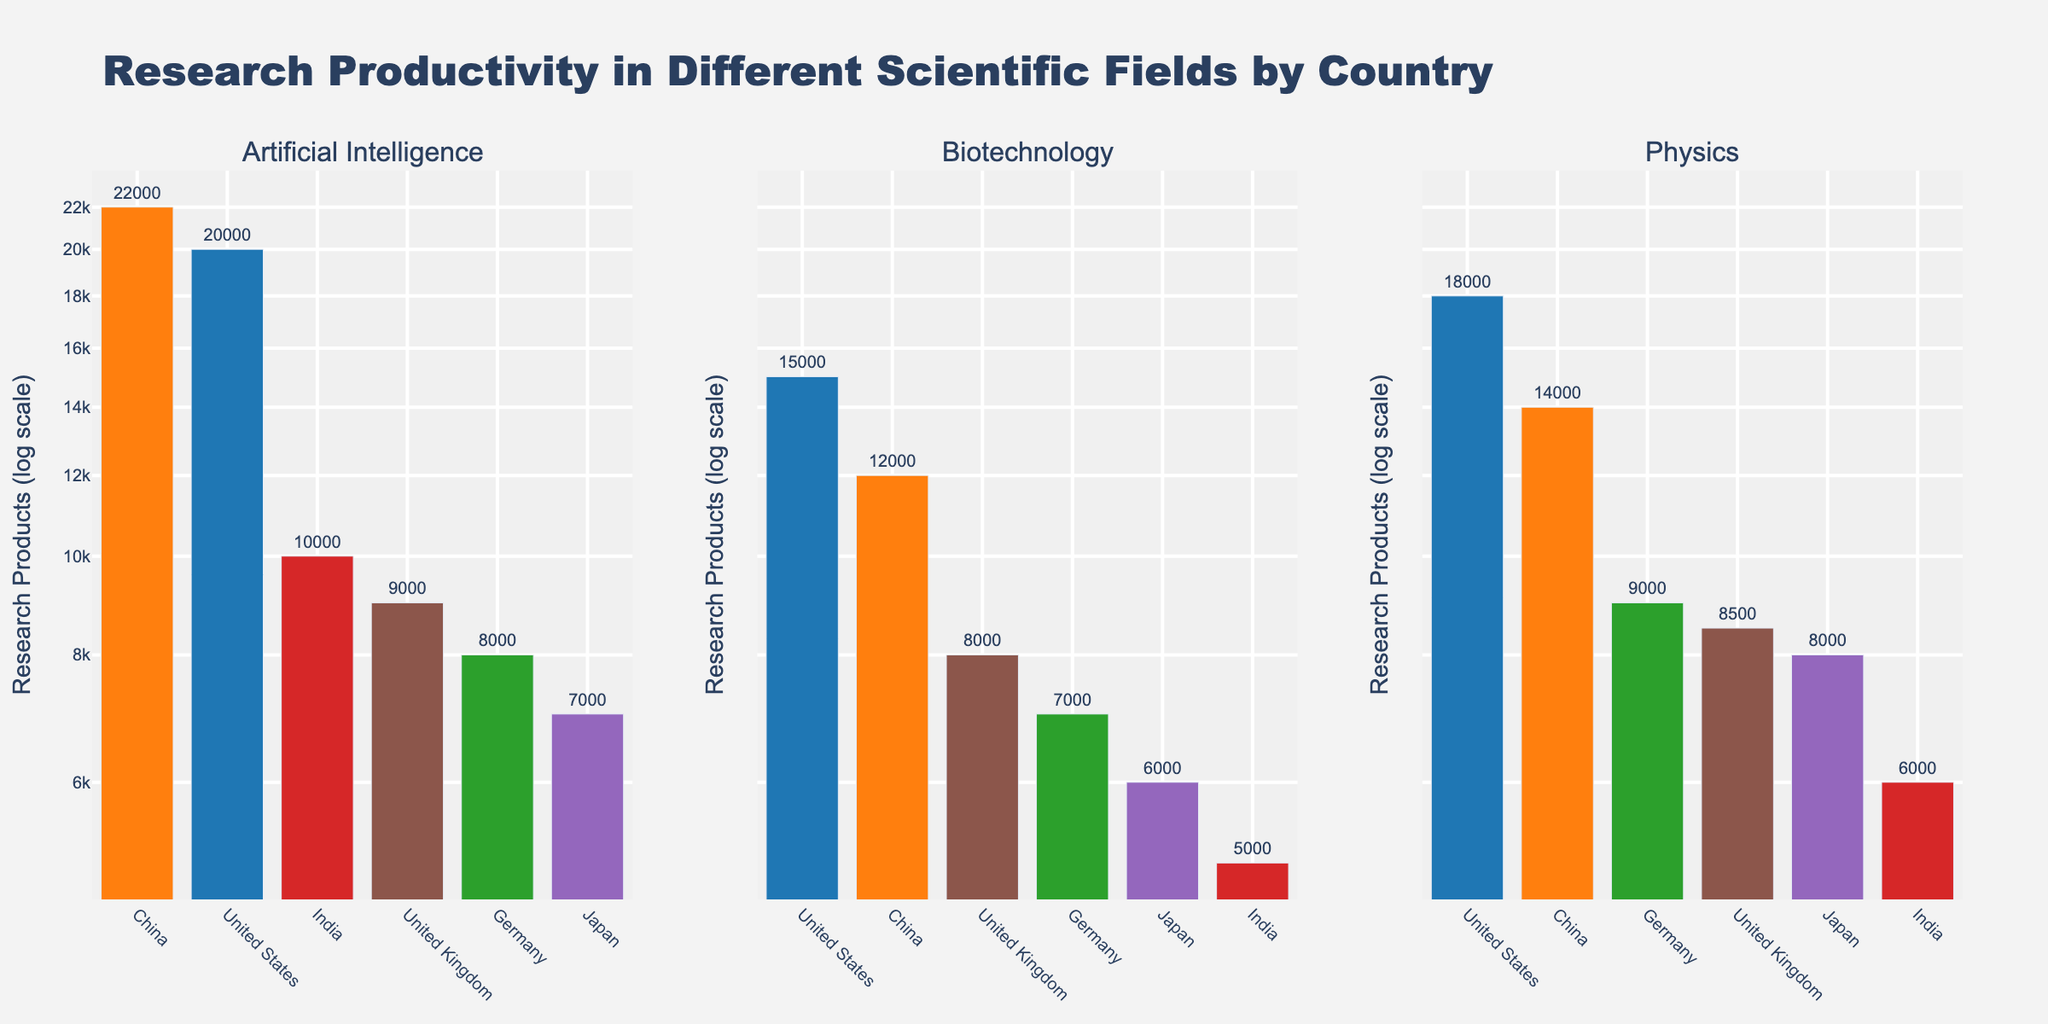Which country has the highest research productivity in Artificial Intelligence? By examining the first subplot titled 'Artificial Intelligence', the bar representing China is the tallest, indicating China has the highest research productivity of 22,000.
Answer: China What is the range of research products in Biotechnology? To find the range, subtract the smallest number of research products from the largest within the Biotechnology subplot. The maximum is 15,000 (United States) and the minimum is 5,000 (India). Therefore, the range is 15,000 - 5,000 = 10,000.
Answer: 10,000 How do India and Japan compare in terms of research productivity in Physics? In the Physics subplot, the bars show that India has 6,000 research products while Japan has 8,000 research products. Comparing these values, Japan has more research productivity.
Answer: Japan has more What is the median value of research productivity for Biotechnology? To find the median, list the research productivity values in ascending order: 5,000 (India), 6,000 (Japan), 7,000 (Germany), 8,000 (United Kingdom), 12,000 (China), and 15,000 (United States). With 6 values, the median lies between the 3rd and 4th values. Thus, (7,000 + 8,000) / 2 = 7,500.
Answer: 7,500 Which country has the smallest variation in research productivity across the three fields? Calculate the range for each country. For the United States: 20,000 - 15,000 = 5,000; for China: 22,000 - 12,000 = 10,000; for Germany: 9,000 - 7,000 = 2,000; for India: 10,000 - 5,000 = 5,000; for Japan: 8,000 - 6,000 = 2,000; for the United Kingdom: 9,000 - 8,000 = 1,000. The United Kingdom has the smallest variation.
Answer: United Kingdom What is the sum of research products in Artificial Intelligence for all countries combined? Adding up the values for Artificial Intelligence from each country: 20,000 (United States) + 22,000 (China) + 8,000 (Germany) + 10,000 (India) + 7,000 (Japan) + 9,000 (United Kingdom) = 76,000.
Answer: 76,000 Is the research productivity in Physics for Germany higher or lower than that of the United Kingdom? By looking at the Physics subplot, Germany has 9,000 research products and the United Kingdom has 8,500 research products. Therefore, Germany has higher research productivity in Physics.
Answer: Higher 